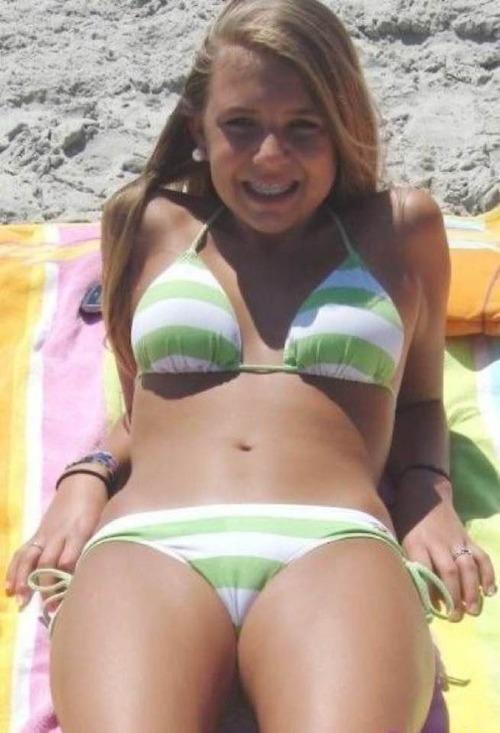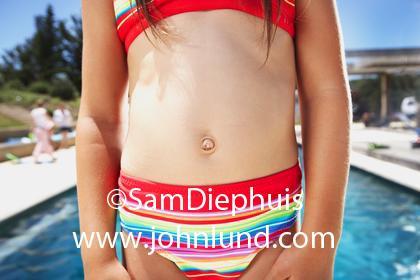The first image is the image on the left, the second image is the image on the right. Analyze the images presented: Is the assertion "One image shows at least three females standing in a line wearing bikinis." valid? Answer yes or no. No. The first image is the image on the left, the second image is the image on the right. Considering the images on both sides, is "An image shows a camera-facing row of at least three girls, each standing and wearing a different swimsuit color." valid? Answer yes or no. No. 